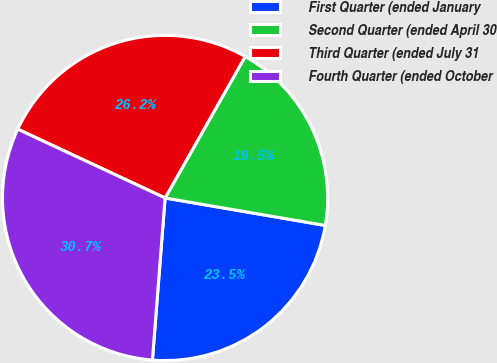Convert chart to OTSL. <chart><loc_0><loc_0><loc_500><loc_500><pie_chart><fcel>First Quarter (ended January<fcel>Second Quarter (ended April 30<fcel>Third Quarter (ended July 31<fcel>Fourth Quarter (ended October<nl><fcel>23.54%<fcel>19.5%<fcel>26.25%<fcel>30.71%<nl></chart> 